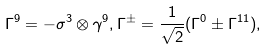Convert formula to latex. <formula><loc_0><loc_0><loc_500><loc_500>\Gamma ^ { 9 } = - \sigma ^ { 3 } \otimes \gamma ^ { 9 } , \Gamma ^ { \pm } = \frac { 1 } { \sqrt { 2 } } ( \Gamma ^ { 0 } \pm \Gamma ^ { 1 1 } ) ,</formula> 